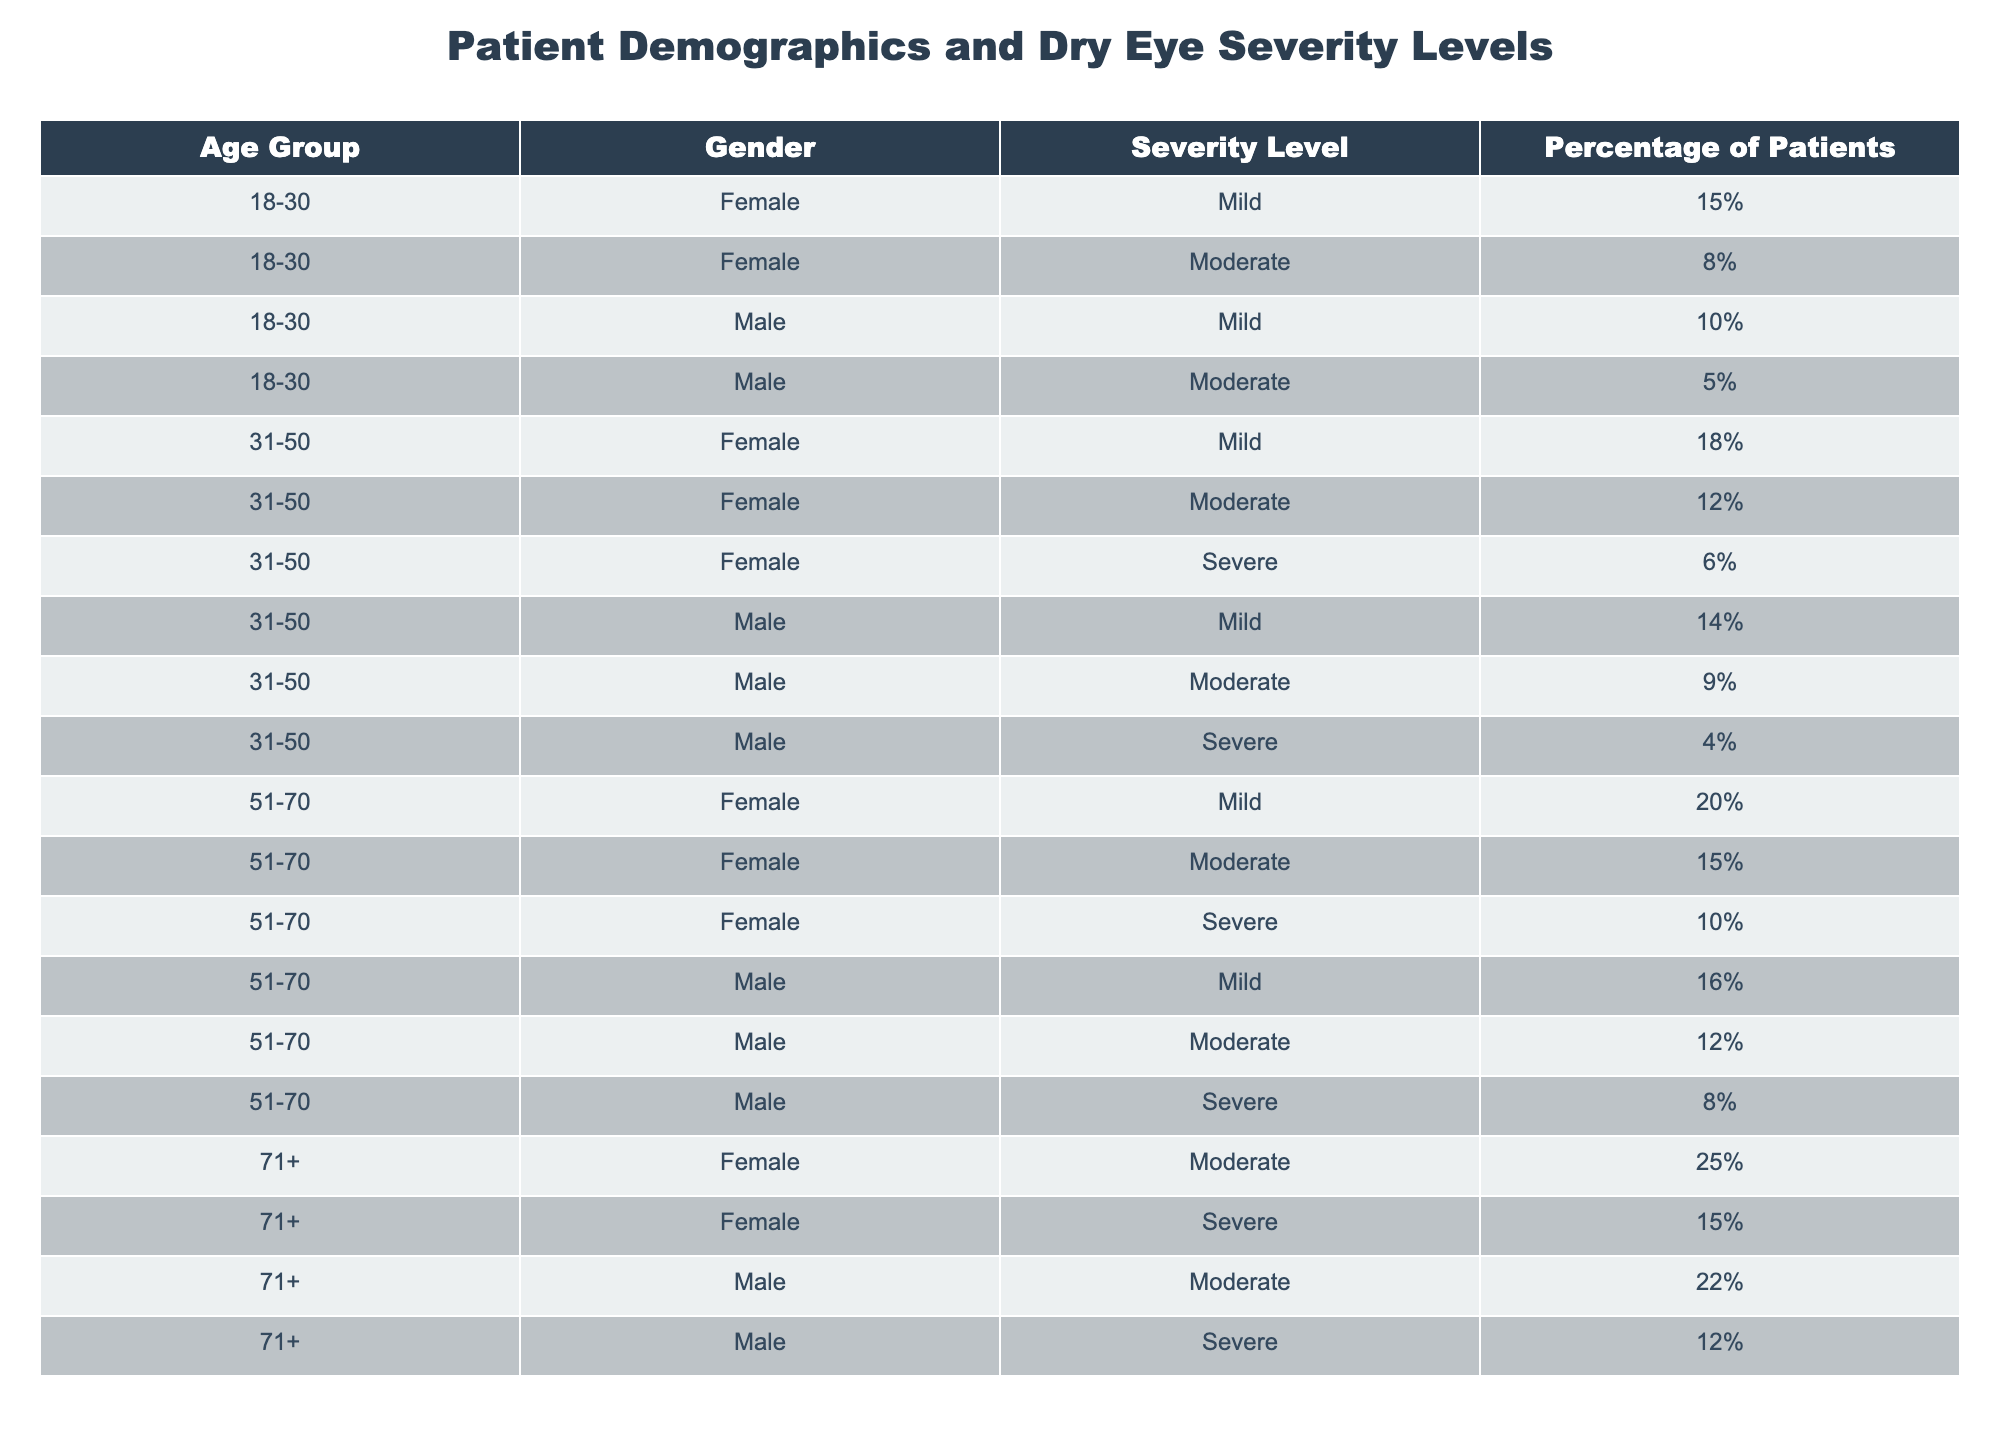What percentage of male patients aged 51-70 have moderate dry eye severity? In the table, for the age group 51-70, there is one entry for male patients with moderate severity, which shows a percentage of 12%.
Answer: 12% What is the total percentage of patients aged 31-50 experiencing mild dry eye severity? For the age group 31-50, we find two entries for mild severity: 18% for females and 14% for males. Adding these percentages gives us 18% + 14% = 32%.
Answer: 32% True or False: The percentage of females with severe dry eye in the age group 71+ is greater than that of males in the same age group. In the 71+ age group, the percentage for females with severe dry eye is 15%, while for males it is 12%. Since 15% is indeed greater than 12%, the statement is true.
Answer: True What age group has the highest percentage of patients with mild dry eye severity? By checking the table, we see the percentages for mild severity in each age group: 15% (18-30), 18% (31-50), 20% (51-70), and no entry for 71+. The highest percentage is 20% in the age group 51-70.
Answer: 51-70 How many patients aged 71+ have severe dry eye severity in total? In the age group 71+, we have females with a severe percentage of 15% and males with 12%. Adding these, we find 15% + 12% = 27%.
Answer: 27% 